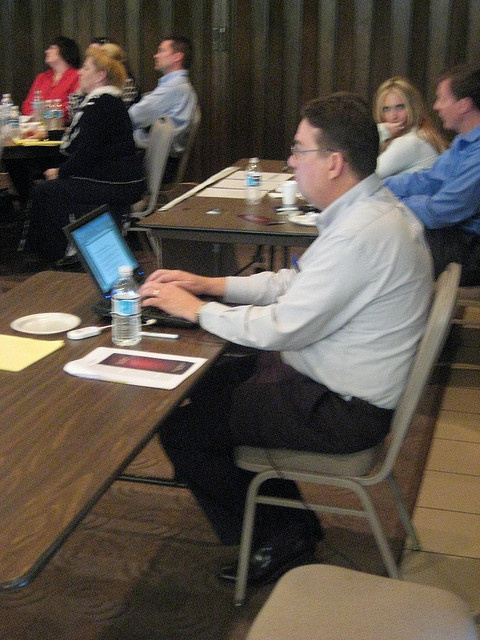Describe the objects in this image and their specific colors. I can see people in black, darkgray, lightgray, and gray tones, dining table in black, gray, and ivory tones, chair in black and gray tones, people in black, gray, and tan tones, and chair in black and gray tones in this image. 